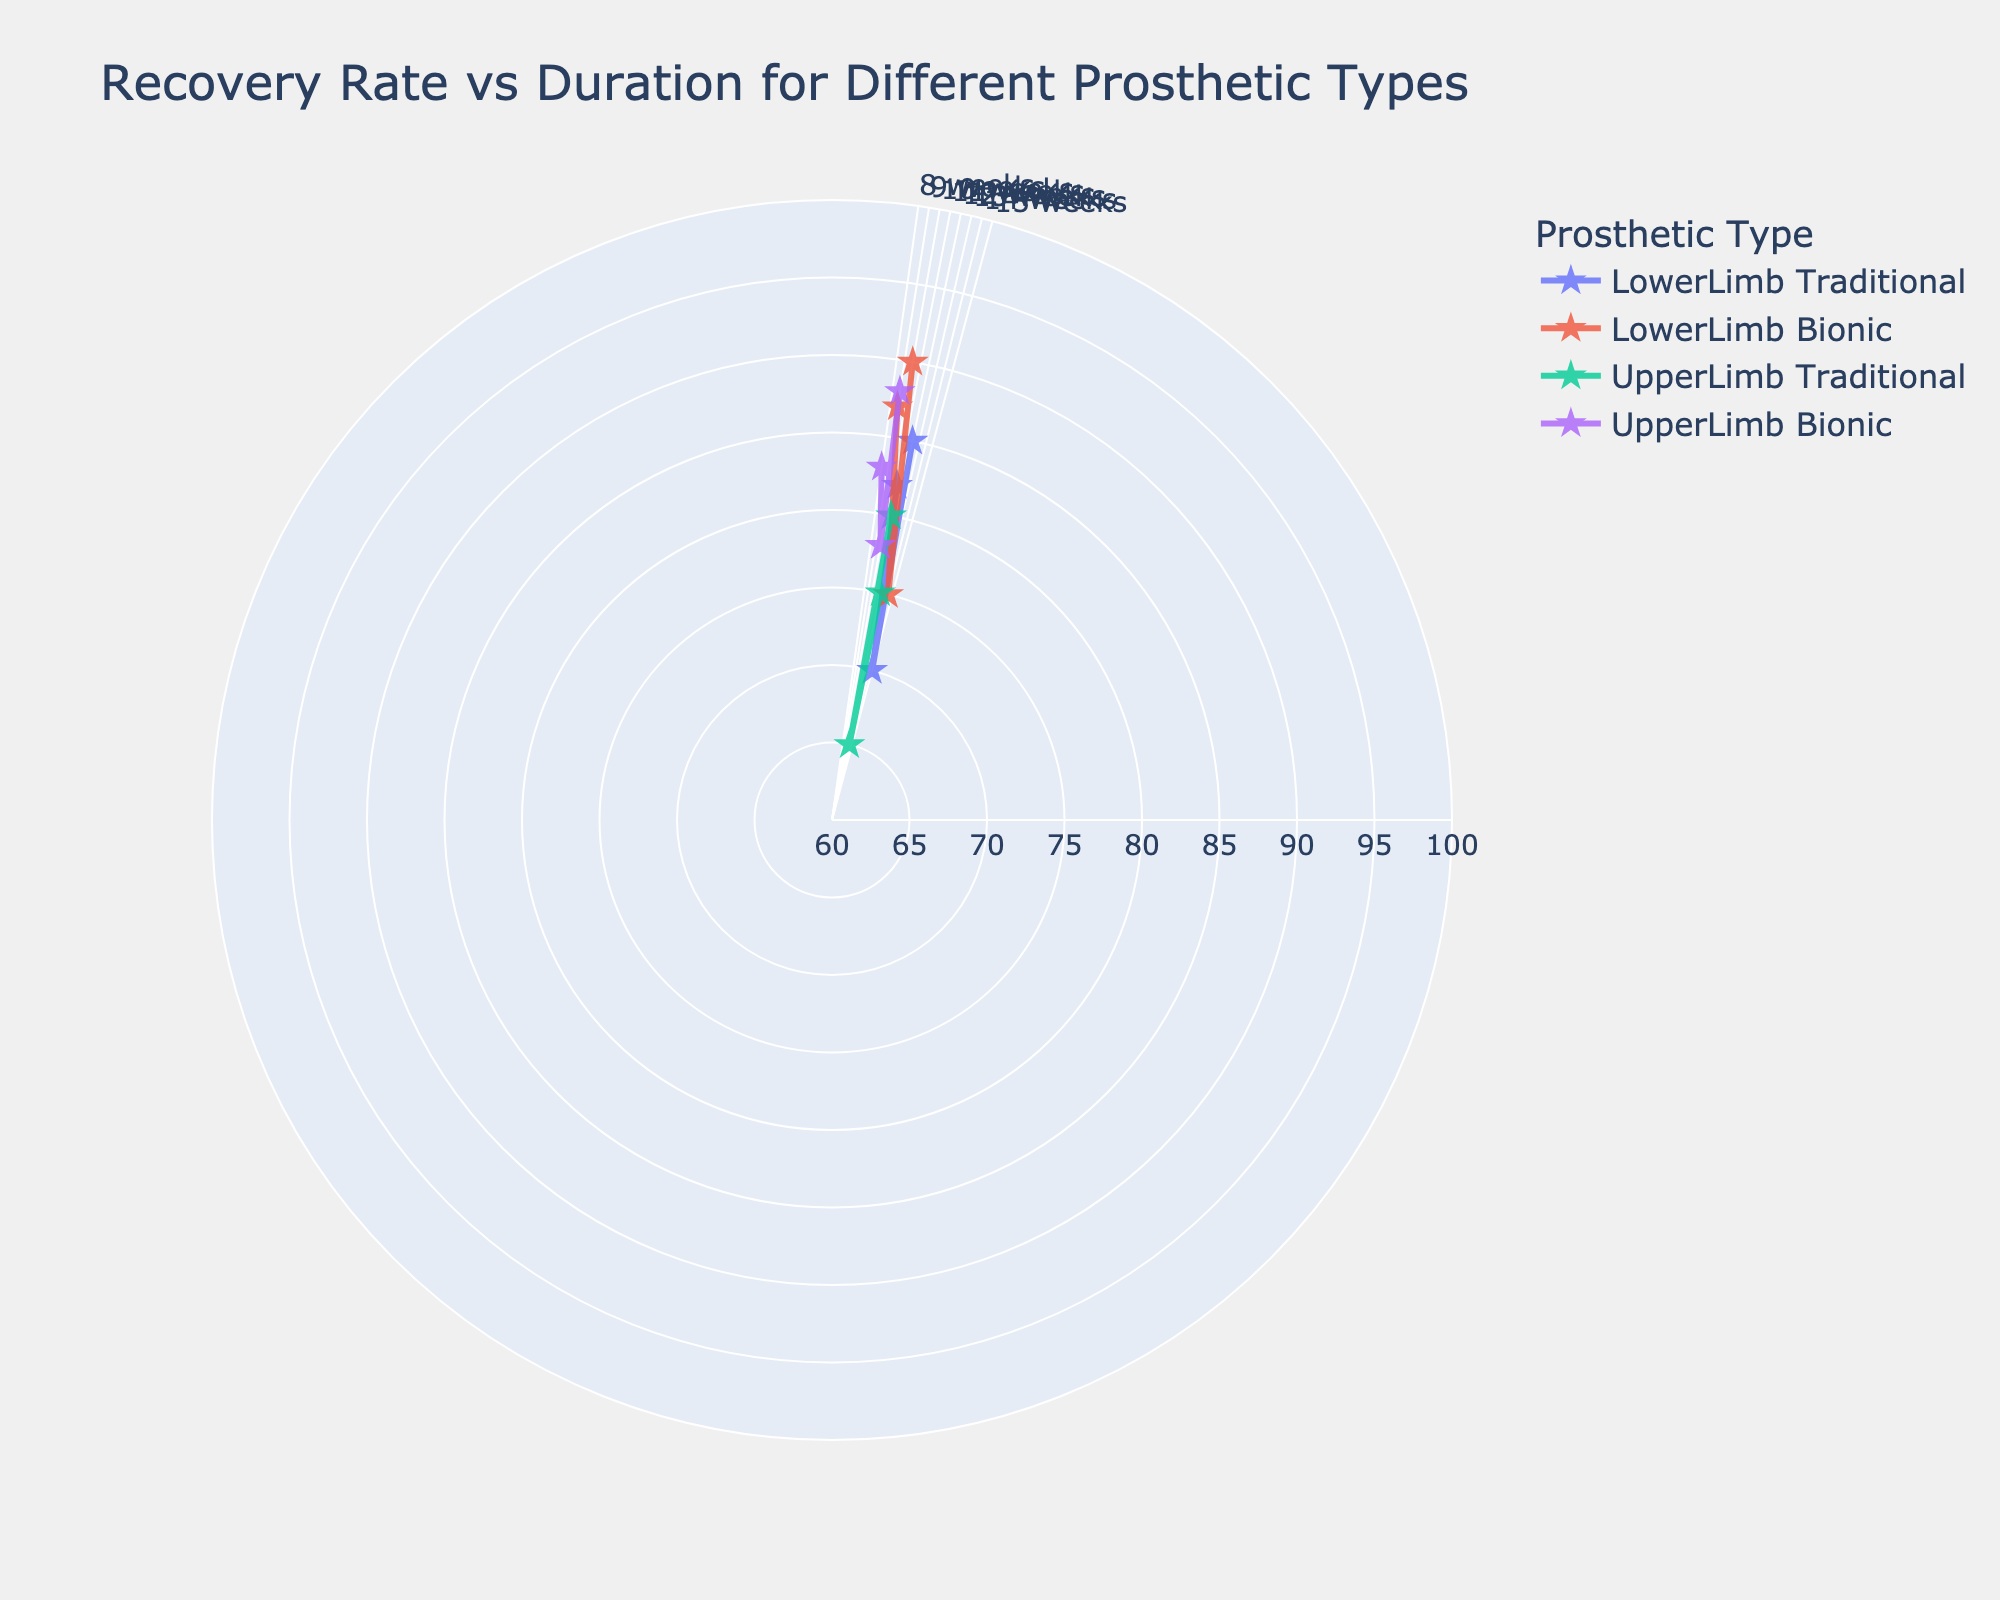What's the title of the figure? The title is always placed at the top of the figure. In this case, it reads "Recovery Rate vs Duration for Different Prosthetic Types."
Answer: Recovery Rate vs Duration for Different Prosthetic Types How many different prosthetic types are represented in the plot? Look at the legend in the plot, which lists the different prosthetic types. There are four entries: LowerLimb Traditional, LowerLimb Bionic, UpperLimb Traditional, and UpperLimb Bionic.
Answer: 4 Which prosthetic type has the highest recovery rate? By examining the radial distance for each series on the chart, the one with the greatest distance from the center represents the highest recovery rate. This is LowerLimb Bionic with a recovery rate around 90.
Answer: LowerLimb Bionic What's the recovery duration for UpperLimb Bionic prosthetics with an 83 recovery rate? Locate the UpperLimb Bionic data points and find the one with a recovery rate closest to 83 on the radial axis. Then, look at its position on the angular axis. It corresponds to 8 weeks.
Answer: 8 weeks Which prosthetic type has the most rapid approximate recovery duration? Identify the prosthetic type with the lowest recovery duration value on the angular axis. UpperLimb Bionic has points at 8 and 9 weeks, which are the lowest values on the chart.
Answer: UpperLimb Bionic What is the average recovery rate for LowerLimb Traditional prosthetics given in the figure? Sum up all the recovery rates for LowerLimb Traditional (85, 70, 82) and divide by their count (3). (85+70+82)/3 = 237/3 = 79.
Answer: 79 Which prosthetic type shows a recovery duration of 10 weeks? Look at the angular axis to find markers at the 10-week position. Both LowerLimb Bionic and UpperLimb Bionic have points at this recovery duration.
Answer: LowerLimb Bionic and UpperLimb Bionic How does the recovery rate at 12 weeks for LowerLimb Traditional compare to UpperLimb Traditional prosthetics? Find both prosthetic types with 12 weeks on the angular axis. LowerLimb Traditional has a recovery rate of 85, while UpperLimb Traditional has 75, indicating that LowerLimb Traditional has a higher recovery rate.
Answer: LowerLimb Traditional has a higher recovery rate What's the median recovery rate among all LowerLimb Bionic prosthetics in the figure? List all recovery rates for LowerLimb Bionic (90, 75, 87) and find the median. The sorted values are 75, 87, 90, so the median is the middle value, which is 87.
Answer: 87 For prosthetic types with 9-week durations, which has the highest recovery rate? Locate the 9-week duration on the angular axis and compare recovery rates for corresponding points. LowerLimb Bionic at 90 and UpperLimb Bionic at 88 show that LowerLimb Bionic has the highest recovery rate.
Answer: LowerLimb Bionic 